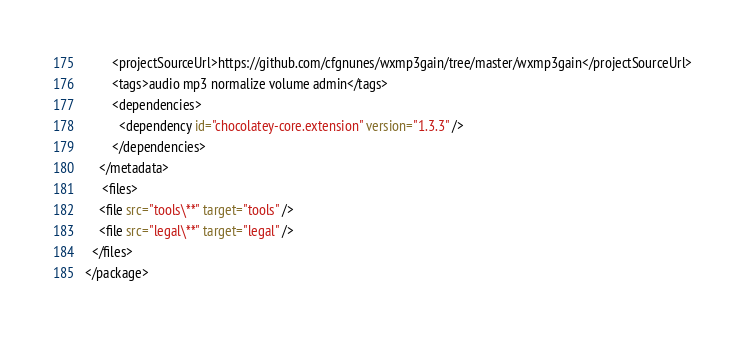<code> <loc_0><loc_0><loc_500><loc_500><_XML_>		<projectSourceUrl>https://github.com/cfgnunes/wxmp3gain/tree/master/wxmp3gain</projectSourceUrl>
        <tags>audio mp3 normalize volume admin</tags>
        <dependencies>
		  <dependency id="chocolatey-core.extension" version="1.3.3" />
        </dependencies>
    </metadata>
	 <files>
    <file src="tools\**" target="tools" />
	<file src="legal\**" target="legal" />
  </files>
</package></code> 